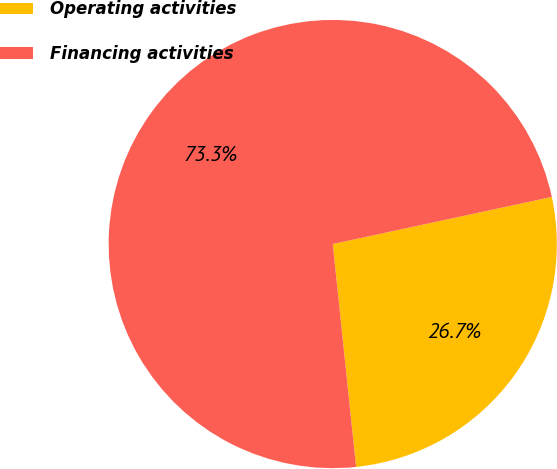Convert chart. <chart><loc_0><loc_0><loc_500><loc_500><pie_chart><fcel>Operating activities<fcel>Financing activities<nl><fcel>26.71%<fcel>73.29%<nl></chart> 